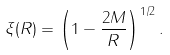<formula> <loc_0><loc_0><loc_500><loc_500>\xi ( R ) = \left ( 1 - \frac { 2 M } { R } \right ) ^ { 1 / 2 } .</formula> 